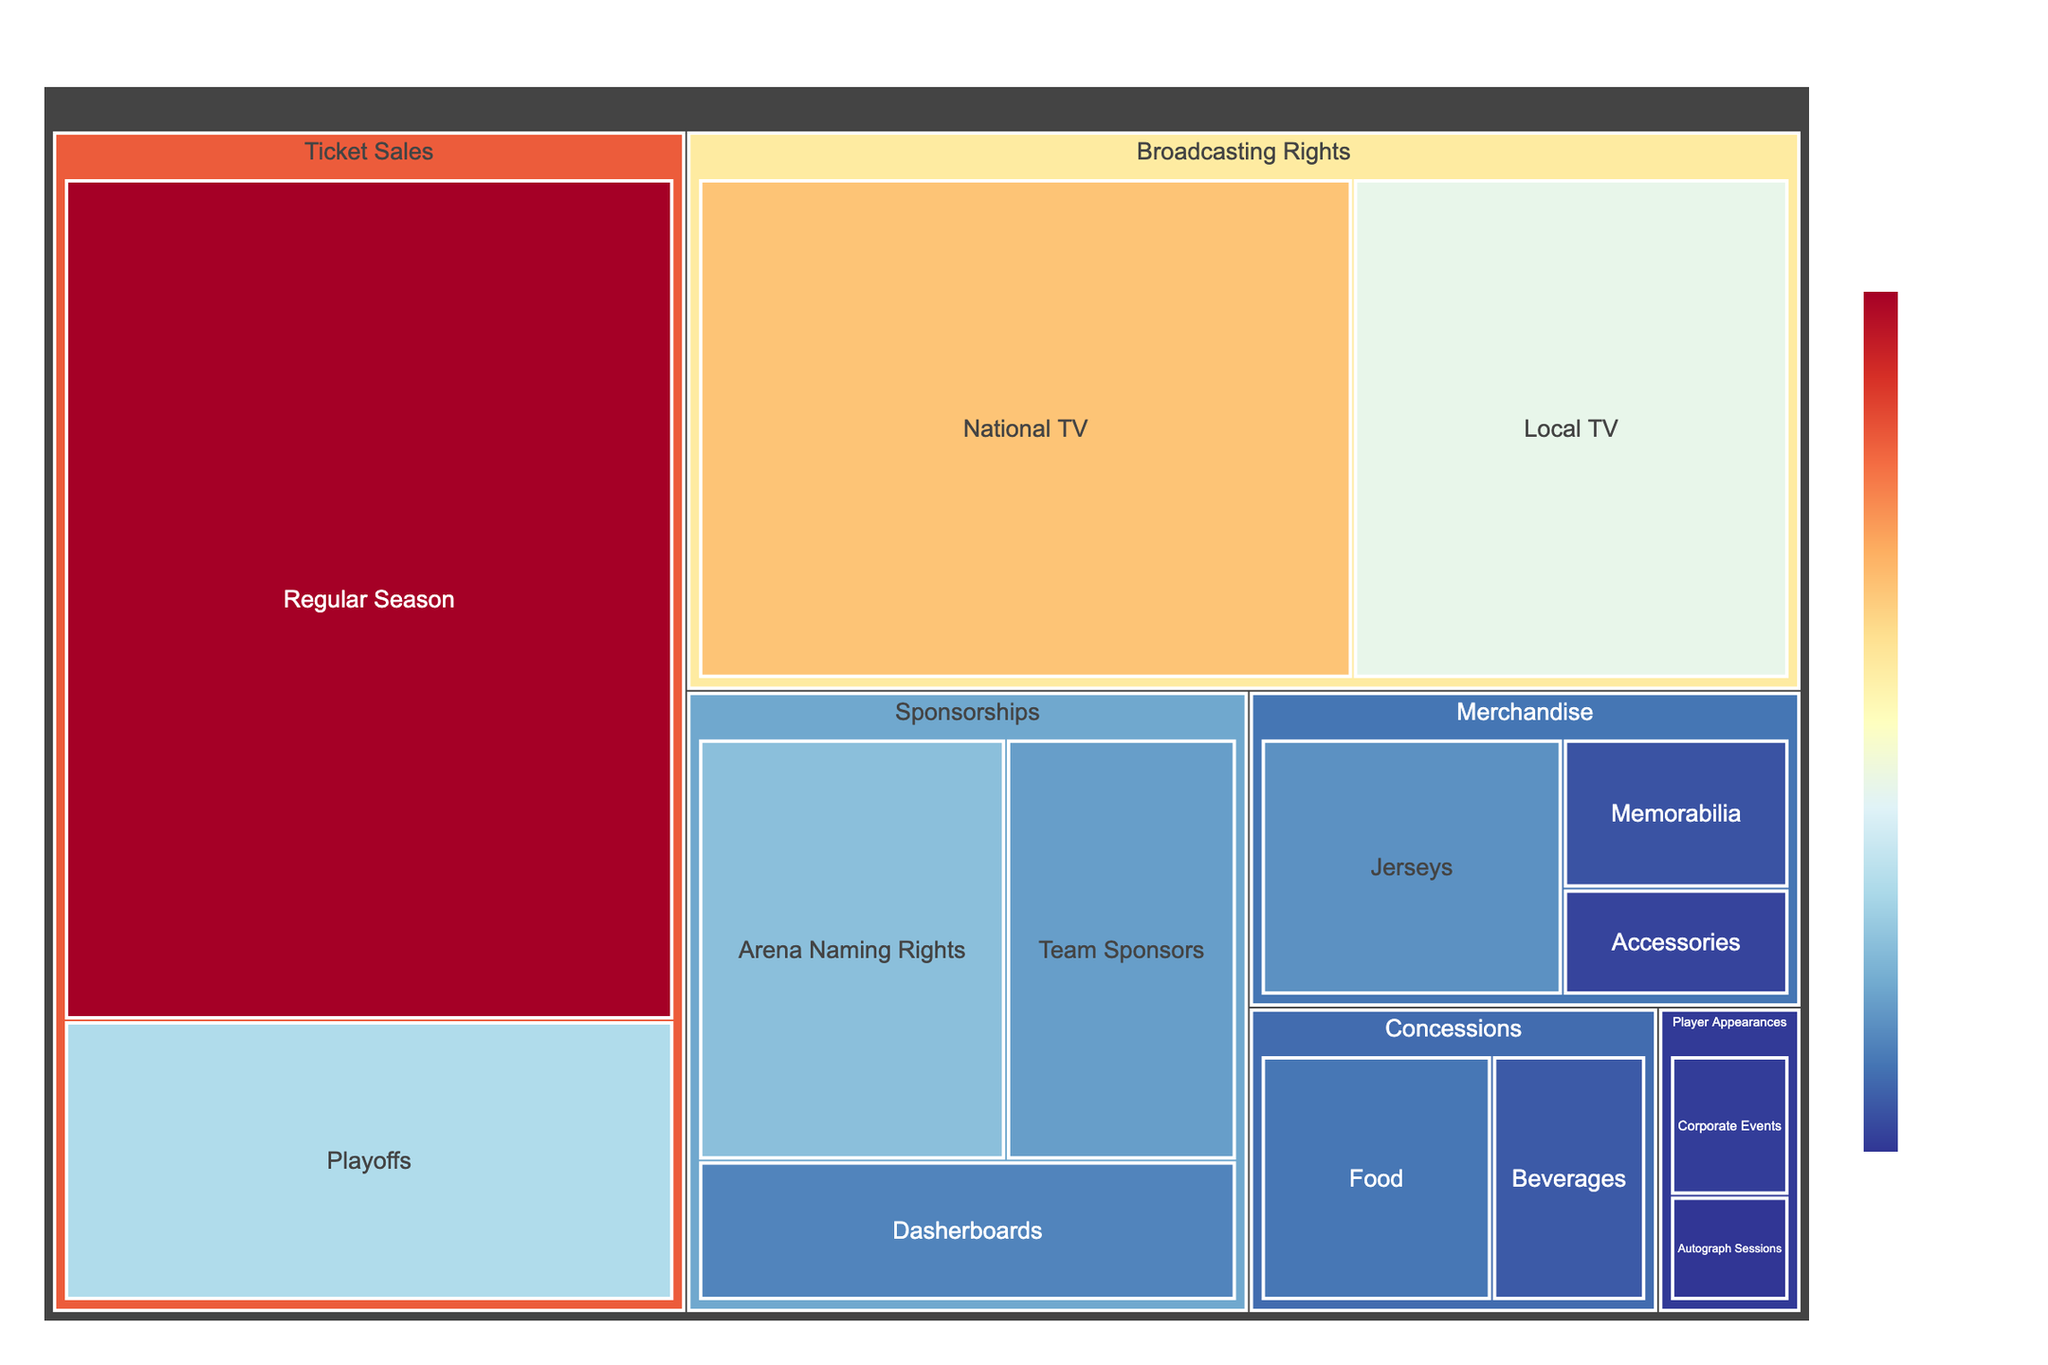What's the title of the figure? The title is displayed prominently at the top of the figure.
Answer: Revenue Sources for Professional Hockey Teams What revenue category contributes the most overall? By looking at the largest areas in the treemap, you can identify that "Ticket Sales" contributes the most overall.
Answer: Ticket Sales Which subcategory within Sponsorships generates the highest revenue? Within the Sponsorships category, find the subcategory with the largest area, which is "Arena Naming Rights" with $12,000,000.
Answer: Arena Naming Rights How much revenue do Playoff ticket sales generate? Locate the Playoffs subcategory under Ticket Sales, which shows a revenue value of $15,000,000.
Answer: $15,000,000 What is the combined revenue from all subcategories within Merchandise? Add all revenue values from Jerseys ($8,000,000), Memorabilia ($3,500,000), and Accessories ($2,500,000). The total combined revenue is $8,000,000 + $3,500,000 + $2,500,000 = $14,000,000.
Answer: $14,000,000 Which generates more revenue: National TV or Local TV Broadcasting Rights? Compare the revenue values of National TV ($30,000,000) and Local TV ($20,000,000). National TV generates more revenue.
Answer: National TV What is the smallest revenue source under Player Appearances? Under the Player Appearances category, compare the revenues for Autograph Sessions ($1,500,000) and Corporate Events ($2,000,000). The smallest revenue source is Autograph Sessions.
Answer: Autograph Sessions By how much does the revenue from Regular Season ticket sales exceed the total revenue from Concessions? Regular Season ticket sales generate $45,000,000, while Concessions generate $6,000,000 + $4,000,000 = $10,000,000. The difference is $45,000,000 - $10,000,000 = $35,000,000.
Answer: $35,000,000 What's the total revenue for all Sponsorships subcategories combined? Sum the revenues for Arena Naming Rights ($12,000,000), Dasherboards ($7,000,000), and Team Sponsors ($9,000,000). The total is $12,000,000 + $7,000,000 + $9,000,000 = $28,000,000.
Answer: $28,000,000 How does the revenue from Concessions compare to the revenue from Player Appearances? Calculate the revenue for Concessions ($6,000,000 + $4,000,000 = $10,000,000) and Player Appearances ($1,500,000 + $2,000,000 = $3,500,000). Concessions generate more revenue.
Answer: Concessions What is the total revenue across all categories? Add the revenues from all subcategories: $45,000,000 + $15,000,000 + $8,000,000 + $3,500,000 + $2,500,000 + $12,000,000 + $7,000,000 + $9,000,000 + $30,000,000 + $20,000,000 + $6,000,000 + $4,000,000 + $1,500,000 + $2,000,000 = $165,500,000.
Answer: $165,500,000 